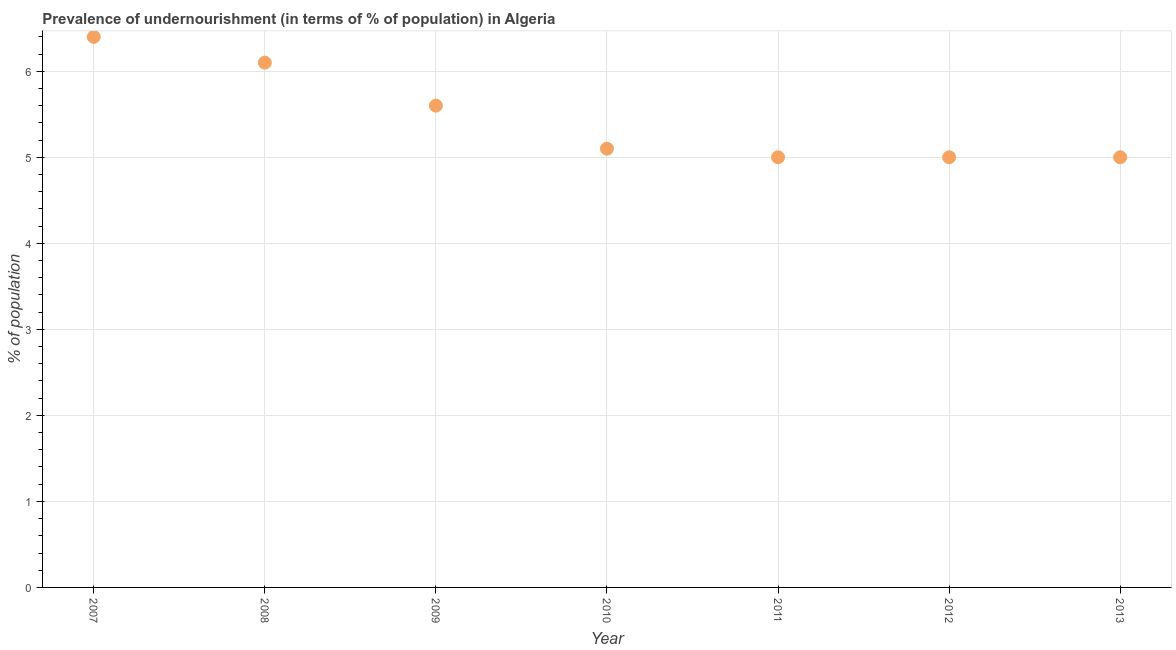Across all years, what is the minimum percentage of undernourished population?
Offer a terse response. 5. What is the sum of the percentage of undernourished population?
Your response must be concise. 38.2. What is the average percentage of undernourished population per year?
Your response must be concise. 5.46. In how many years, is the percentage of undernourished population greater than 5 %?
Provide a short and direct response. 4. Do a majority of the years between 2010 and 2008 (inclusive) have percentage of undernourished population greater than 6 %?
Offer a terse response. No. What is the ratio of the percentage of undernourished population in 2009 to that in 2013?
Ensure brevity in your answer.  1.12. Is the percentage of undernourished population in 2007 less than that in 2011?
Ensure brevity in your answer.  No. Is the difference between the percentage of undernourished population in 2007 and 2013 greater than the difference between any two years?
Ensure brevity in your answer.  Yes. What is the difference between the highest and the second highest percentage of undernourished population?
Give a very brief answer. 0.3. What is the difference between the highest and the lowest percentage of undernourished population?
Offer a terse response. 1.4. In how many years, is the percentage of undernourished population greater than the average percentage of undernourished population taken over all years?
Your response must be concise. 3. Does the percentage of undernourished population monotonically increase over the years?
Offer a terse response. No. How many dotlines are there?
Give a very brief answer. 1. What is the title of the graph?
Make the answer very short. Prevalence of undernourishment (in terms of % of population) in Algeria. What is the label or title of the X-axis?
Ensure brevity in your answer.  Year. What is the label or title of the Y-axis?
Provide a short and direct response. % of population. What is the % of population in 2009?
Your answer should be compact. 5.6. What is the % of population in 2010?
Offer a terse response. 5.1. What is the % of population in 2013?
Your answer should be compact. 5. What is the difference between the % of population in 2007 and 2009?
Ensure brevity in your answer.  0.8. What is the difference between the % of population in 2007 and 2010?
Make the answer very short. 1.3. What is the difference between the % of population in 2007 and 2011?
Your response must be concise. 1.4. What is the difference between the % of population in 2008 and 2010?
Give a very brief answer. 1. What is the difference between the % of population in 2008 and 2011?
Give a very brief answer. 1.1. What is the difference between the % of population in 2008 and 2012?
Provide a short and direct response. 1.1. What is the difference between the % of population in 2008 and 2013?
Your response must be concise. 1.1. What is the difference between the % of population in 2009 and 2010?
Your answer should be compact. 0.5. What is the difference between the % of population in 2009 and 2012?
Your answer should be compact. 0.6. What is the difference between the % of population in 2010 and 2011?
Offer a terse response. 0.1. What is the difference between the % of population in 2010 and 2012?
Give a very brief answer. 0.1. What is the difference between the % of population in 2010 and 2013?
Provide a succinct answer. 0.1. What is the difference between the % of population in 2011 and 2012?
Provide a succinct answer. 0. What is the difference between the % of population in 2012 and 2013?
Provide a short and direct response. 0. What is the ratio of the % of population in 2007 to that in 2008?
Offer a terse response. 1.05. What is the ratio of the % of population in 2007 to that in 2009?
Your answer should be very brief. 1.14. What is the ratio of the % of population in 2007 to that in 2010?
Provide a succinct answer. 1.25. What is the ratio of the % of population in 2007 to that in 2011?
Ensure brevity in your answer.  1.28. What is the ratio of the % of population in 2007 to that in 2012?
Your answer should be very brief. 1.28. What is the ratio of the % of population in 2007 to that in 2013?
Give a very brief answer. 1.28. What is the ratio of the % of population in 2008 to that in 2009?
Your answer should be compact. 1.09. What is the ratio of the % of population in 2008 to that in 2010?
Your answer should be compact. 1.2. What is the ratio of the % of population in 2008 to that in 2011?
Keep it short and to the point. 1.22. What is the ratio of the % of population in 2008 to that in 2012?
Provide a short and direct response. 1.22. What is the ratio of the % of population in 2008 to that in 2013?
Your response must be concise. 1.22. What is the ratio of the % of population in 2009 to that in 2010?
Provide a short and direct response. 1.1. What is the ratio of the % of population in 2009 to that in 2011?
Provide a succinct answer. 1.12. What is the ratio of the % of population in 2009 to that in 2012?
Offer a very short reply. 1.12. What is the ratio of the % of population in 2009 to that in 2013?
Keep it short and to the point. 1.12. What is the ratio of the % of population in 2011 to that in 2012?
Your response must be concise. 1. What is the ratio of the % of population in 2011 to that in 2013?
Give a very brief answer. 1. What is the ratio of the % of population in 2012 to that in 2013?
Provide a short and direct response. 1. 